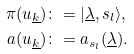Convert formula to latex. <formula><loc_0><loc_0><loc_500><loc_500>\pi ( u _ { \underline { k } } ) & \colon = | \underline { \lambda } , { s } _ { l } \rangle , \\ a ( u _ { \underline { k } } ) & \colon = a _ { { s } _ { l } } ( \underline { \lambda } ) .</formula> 